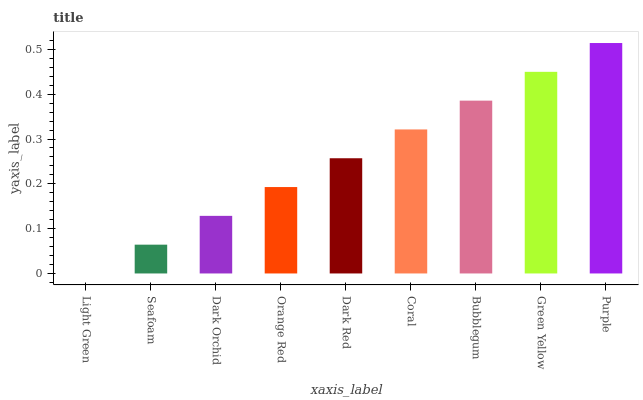Is Light Green the minimum?
Answer yes or no. Yes. Is Purple the maximum?
Answer yes or no. Yes. Is Seafoam the minimum?
Answer yes or no. No. Is Seafoam the maximum?
Answer yes or no. No. Is Seafoam greater than Light Green?
Answer yes or no. Yes. Is Light Green less than Seafoam?
Answer yes or no. Yes. Is Light Green greater than Seafoam?
Answer yes or no. No. Is Seafoam less than Light Green?
Answer yes or no. No. Is Dark Red the high median?
Answer yes or no. Yes. Is Dark Red the low median?
Answer yes or no. Yes. Is Bubblegum the high median?
Answer yes or no. No. Is Orange Red the low median?
Answer yes or no. No. 